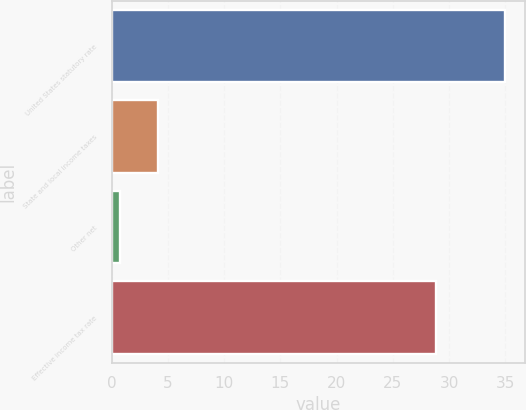Convert chart to OTSL. <chart><loc_0><loc_0><loc_500><loc_500><bar_chart><fcel>United States statutory rate<fcel>State and local income taxes<fcel>Other net<fcel>Effective income tax rate<nl><fcel>35<fcel>4.13<fcel>0.7<fcel>28.8<nl></chart> 